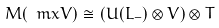Convert formula to latex. <formula><loc_0><loc_0><loc_500><loc_500>M ( \ m x { V } ) \cong ( U ( L _ { - } ) \otimes V ) \otimes T</formula> 